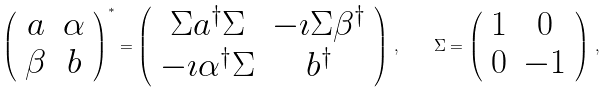<formula> <loc_0><loc_0><loc_500><loc_500>\left ( \begin{array} { c c } a & \alpha \\ \beta & b \end{array} \right ) ^ { * } = \left ( \begin{array} { c c } \Sigma a ^ { \dagger } \Sigma & - \imath \Sigma \beta ^ { \dagger } \\ - \imath \alpha ^ { \dagger } \Sigma & b ^ { \dagger } \end{array} \right ) \, , \quad \Sigma = \left ( \begin{array} { c c } 1 & 0 \\ 0 & - 1 \end{array} \right ) \, ,</formula> 